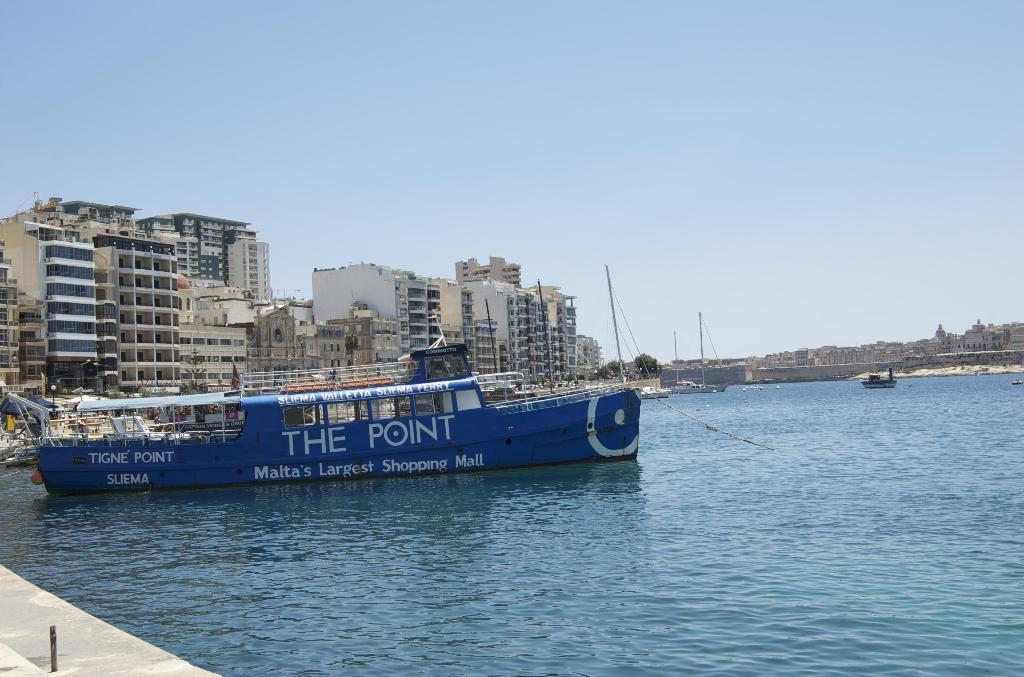Provide a one-sentence caption for the provided image. Blue ship that has the words The Point in white. 